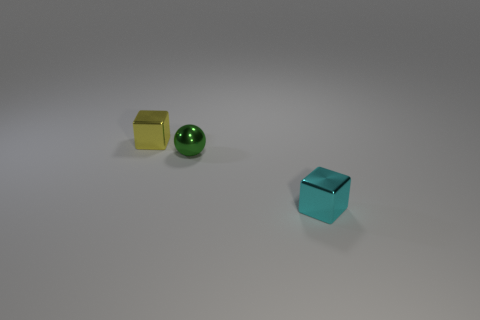What is the small block in front of the yellow metal block made of?
Your answer should be compact. Metal. How many objects are either tiny metallic things to the left of the cyan metallic block or cyan metallic objects?
Offer a terse response. 3. How many other things are there of the same shape as the tiny green shiny object?
Your answer should be very brief. 0. Does the thing that is to the left of the green ball have the same shape as the tiny green object?
Your answer should be compact. No. There is a tiny yellow metallic object; are there any cyan cubes behind it?
Give a very brief answer. No. How many small things are yellow metal cubes or metal things?
Offer a terse response. 3. Do the small ball and the small cyan thing have the same material?
Keep it short and to the point. Yes. There is a cyan object that is the same material as the green object; what is its size?
Offer a terse response. Small. What is the shape of the small green metal object that is behind the cyan shiny thing right of the tiny thing that is behind the green metal ball?
Give a very brief answer. Sphere. There is a thing that is to the left of the cyan metallic thing and right of the small yellow shiny cube; what size is it?
Provide a short and direct response. Small. 